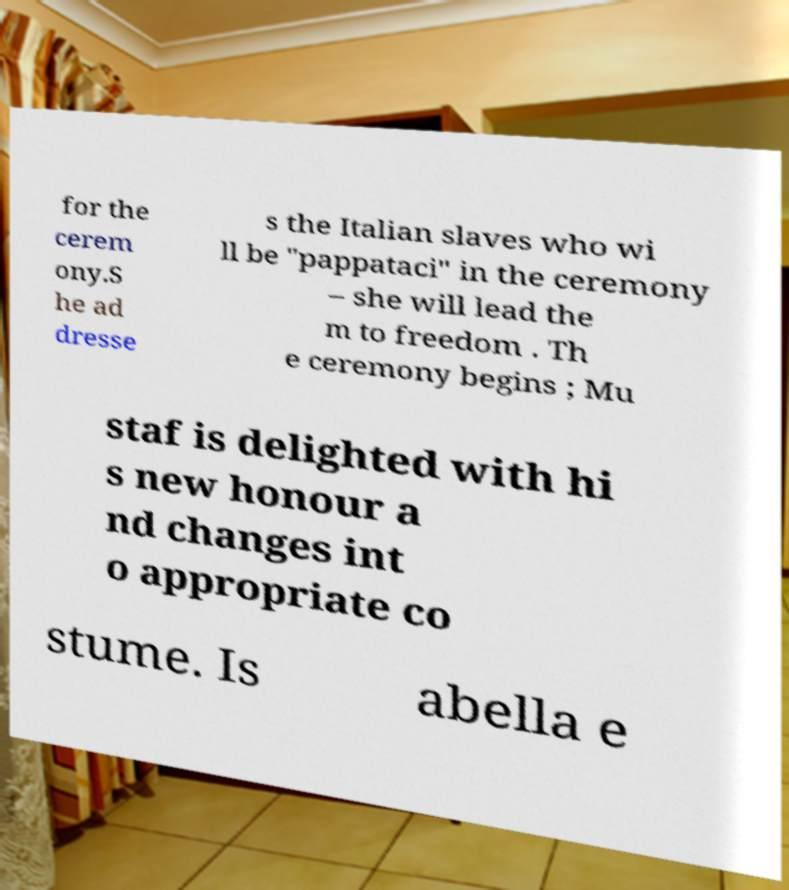For documentation purposes, I need the text within this image transcribed. Could you provide that? for the cerem ony.S he ad dresse s the Italian slaves who wi ll be "pappataci" in the ceremony – she will lead the m to freedom . Th e ceremony begins ; Mu staf is delighted with hi s new honour a nd changes int o appropriate co stume. Is abella e 